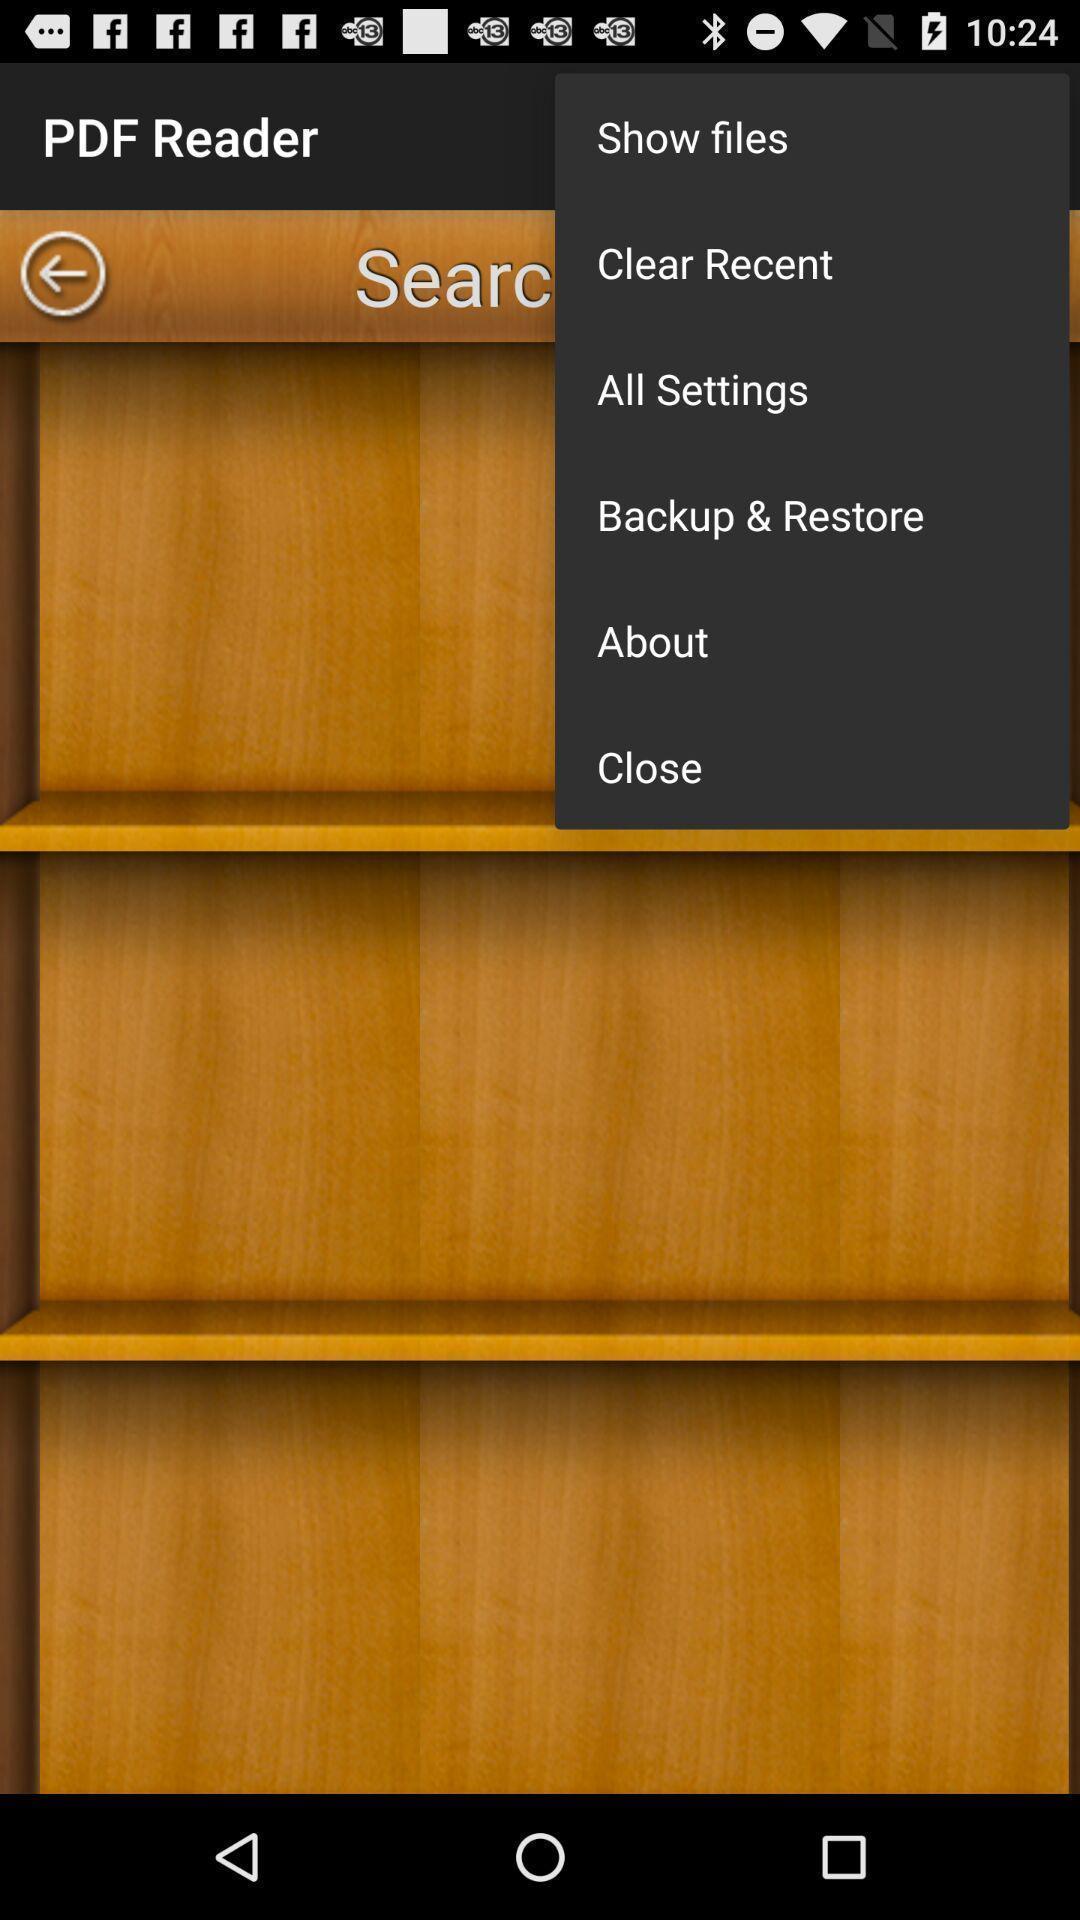Provide a description of this screenshot. Popup displaying multiple settings options. 